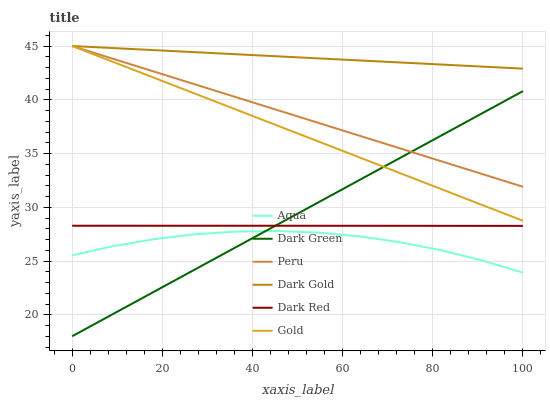Does Aqua have the minimum area under the curve?
Answer yes or no. Yes. Does Dark Gold have the maximum area under the curve?
Answer yes or no. Yes. Does Dark Red have the minimum area under the curve?
Answer yes or no. No. Does Dark Red have the maximum area under the curve?
Answer yes or no. No. Is Gold the smoothest?
Answer yes or no. Yes. Is Aqua the roughest?
Answer yes or no. Yes. Is Dark Gold the smoothest?
Answer yes or no. No. Is Dark Gold the roughest?
Answer yes or no. No. Does Dark Green have the lowest value?
Answer yes or no. Yes. Does Dark Red have the lowest value?
Answer yes or no. No. Does Peru have the highest value?
Answer yes or no. Yes. Does Dark Red have the highest value?
Answer yes or no. No. Is Dark Red less than Gold?
Answer yes or no. Yes. Is Dark Gold greater than Dark Red?
Answer yes or no. Yes. Does Dark Red intersect Dark Green?
Answer yes or no. Yes. Is Dark Red less than Dark Green?
Answer yes or no. No. Is Dark Red greater than Dark Green?
Answer yes or no. No. Does Dark Red intersect Gold?
Answer yes or no. No. 